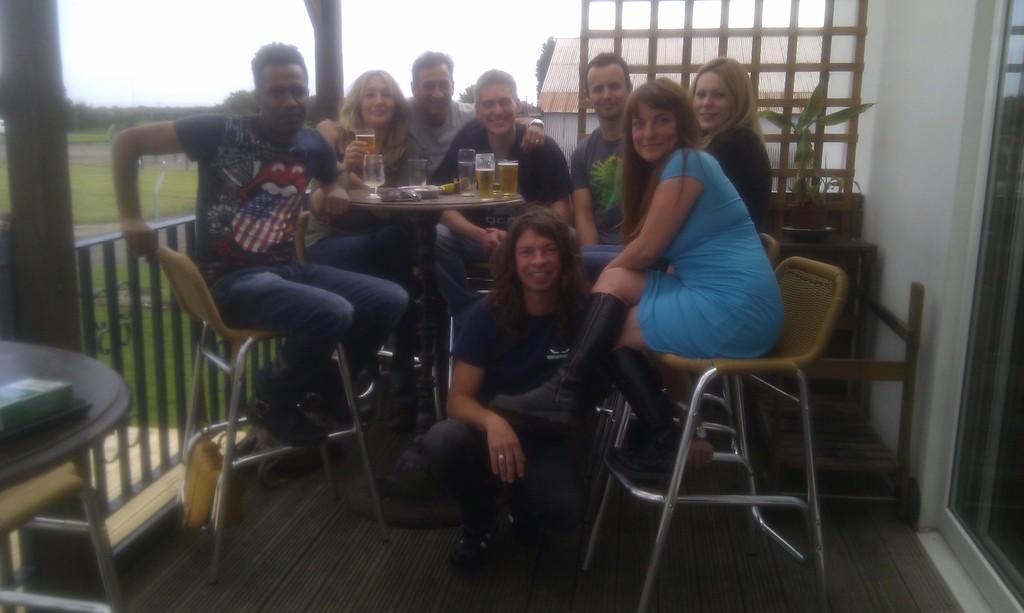Could you give a brief overview of what you see in this image? In this image I can see the group of people. In front of them there are some wine glasses on the table. At the back of them there are some trees,sky and the house. 